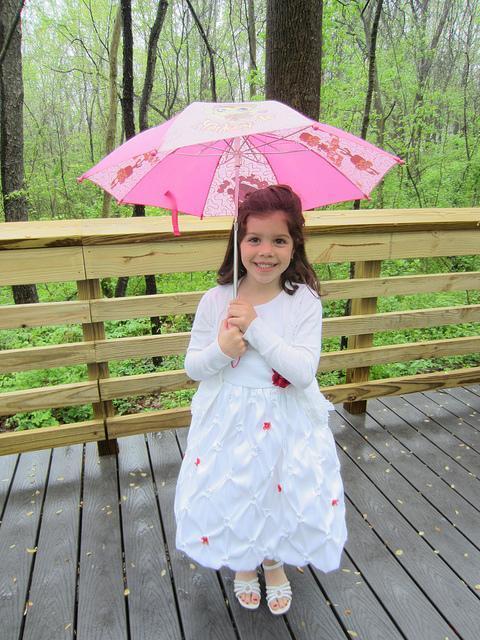How many pairs of scissors in this photo?
Give a very brief answer. 0. 